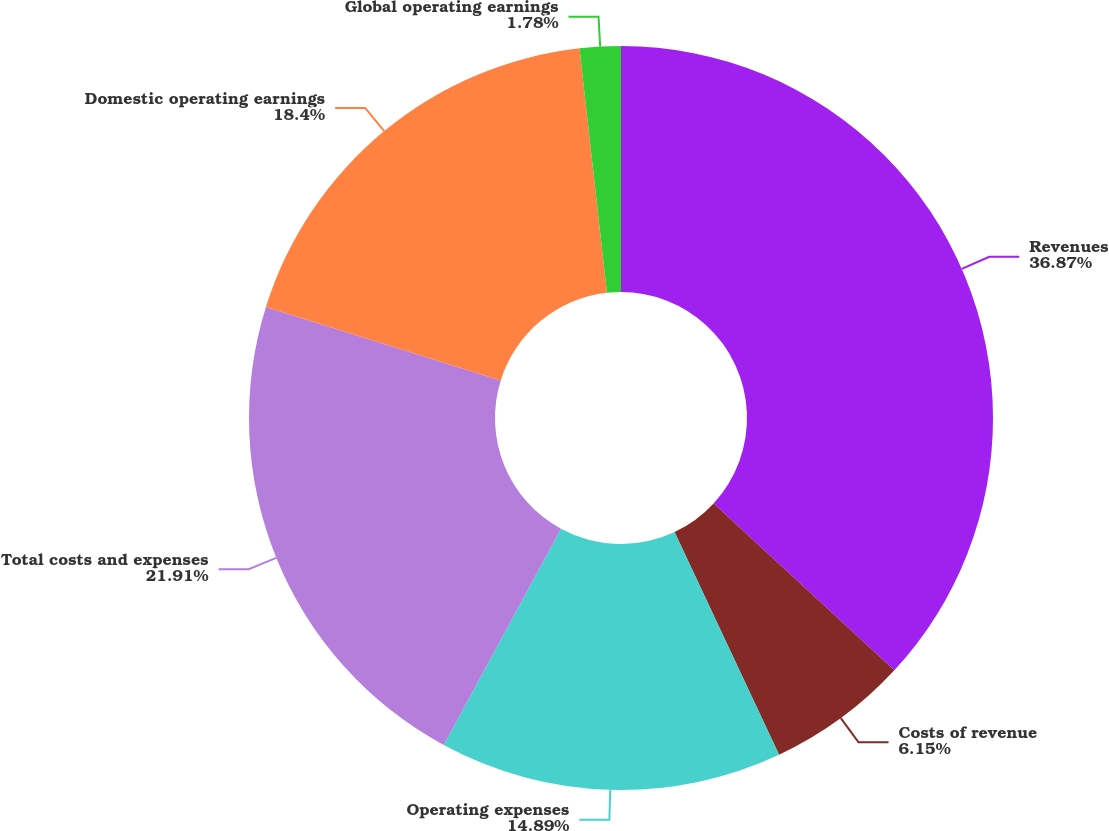<chart> <loc_0><loc_0><loc_500><loc_500><pie_chart><fcel>Revenues<fcel>Costs of revenue<fcel>Operating expenses<fcel>Total costs and expenses<fcel>Domestic operating earnings<fcel>Global operating earnings<nl><fcel>36.86%<fcel>6.15%<fcel>14.89%<fcel>21.91%<fcel>18.4%<fcel>1.78%<nl></chart> 